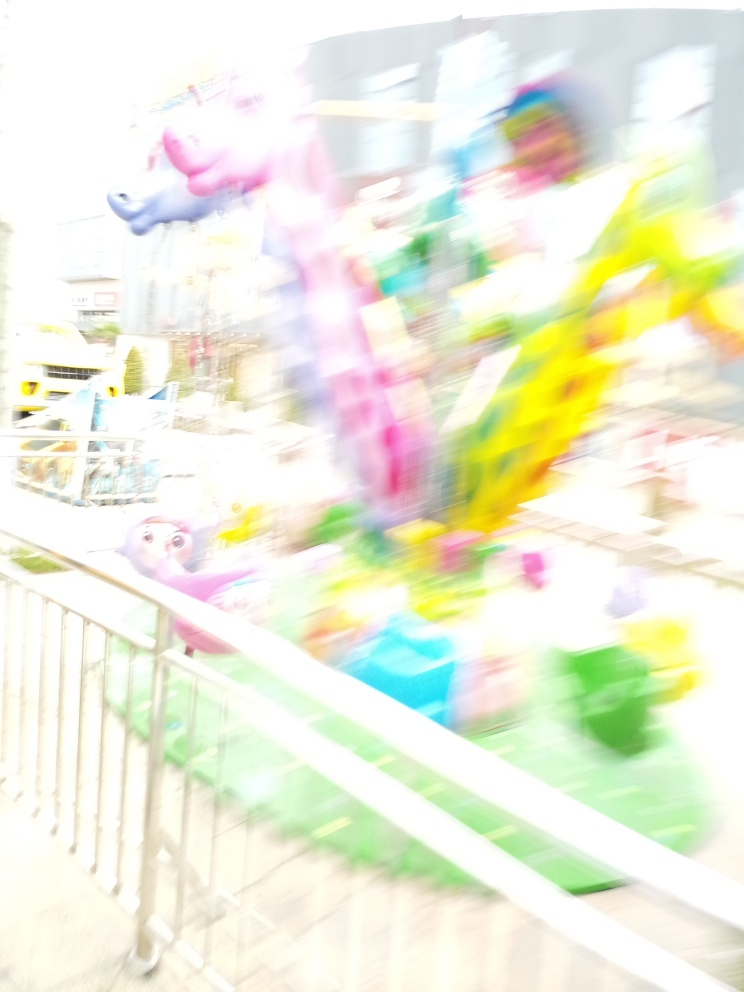Can you describe the colors in the image despite the blurriness? Despite the blurriness, the photograph features a vibrant color palette with prominent hues of pink, blue, yellow, and green. These colors suggest the presence of playful or whimsical elements, likely objects in motion, which add to the dynamic feel of the image. 